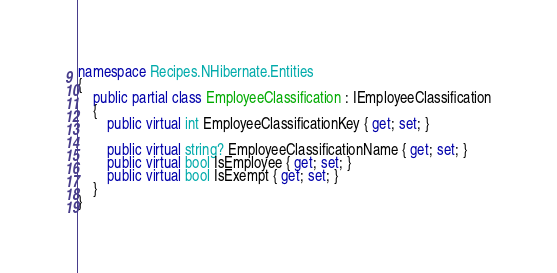<code> <loc_0><loc_0><loc_500><loc_500><_C#_>namespace Recipes.NHibernate.Entities
{
    public partial class EmployeeClassification : IEmployeeClassification
    {
        public virtual int EmployeeClassificationKey { get; set; }

        public virtual string? EmployeeClassificationName { get; set; }
        public virtual bool IsEmployee { get; set; }
        public virtual bool IsExempt { get; set; }
    }
}
</code> 